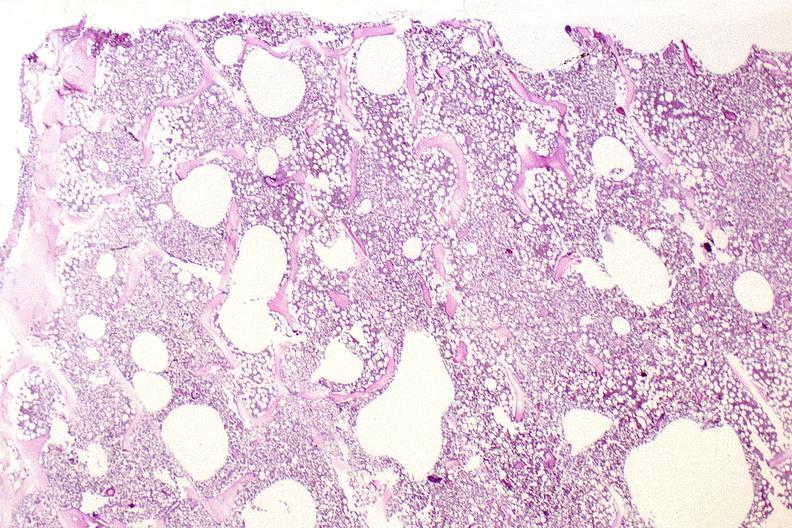what does this image show?
Answer the question using a single word or phrase. Bone 